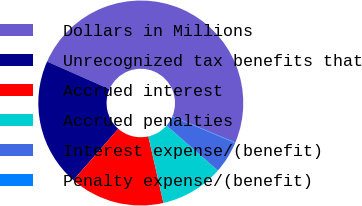Convert chart. <chart><loc_0><loc_0><loc_500><loc_500><pie_chart><fcel>Dollars in Millions<fcel>Unrecognized tax benefits that<fcel>Accrued interest<fcel>Accrued penalties<fcel>Interest expense/(benefit)<fcel>Penalty expense/(benefit)<nl><fcel>49.66%<fcel>20.21%<fcel>14.97%<fcel>10.01%<fcel>5.05%<fcel>0.1%<nl></chart> 